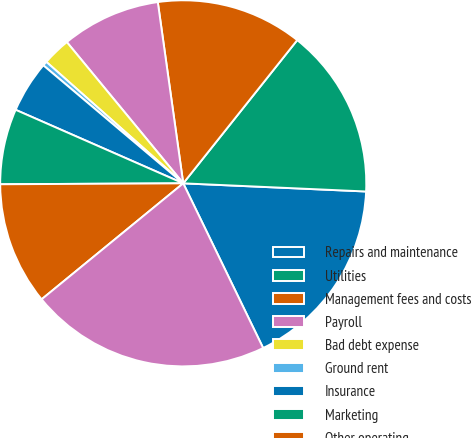<chart> <loc_0><loc_0><loc_500><loc_500><pie_chart><fcel>Repairs and maintenance<fcel>Utilities<fcel>Management fees and costs<fcel>Payroll<fcel>Bad debt expense<fcel>Ground rent<fcel>Insurance<fcel>Marketing<fcel>Other operating<fcel>Total rental expenses<nl><fcel>17.1%<fcel>15.01%<fcel>12.92%<fcel>8.75%<fcel>2.48%<fcel>0.4%<fcel>4.57%<fcel>6.66%<fcel>10.84%<fcel>21.27%<nl></chart> 